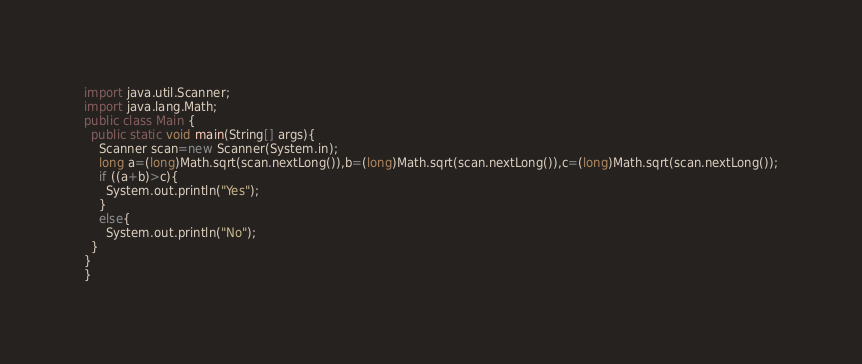Convert code to text. <code><loc_0><loc_0><loc_500><loc_500><_Java_>import java.util.Scanner;
import java.lang.Math;
public class Main {
  public static void main(String[] args){
    Scanner scan=new Scanner(System.in);
    long a=(long)Math.sqrt(scan.nextLong()),b=(long)Math.sqrt(scan.nextLong()),c=(long)Math.sqrt(scan.nextLong());
    if ((a+b)>c){
      System.out.println("Yes");
    }
    else{
      System.out.println("No");
  }
}
}
</code> 